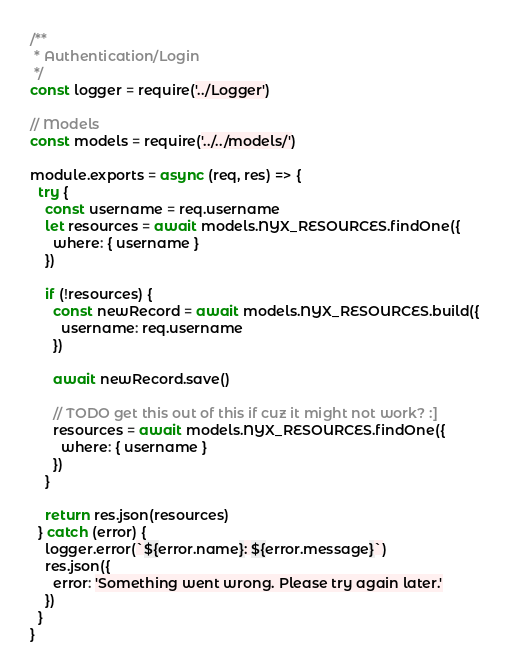<code> <loc_0><loc_0><loc_500><loc_500><_JavaScript_>/**
 * Authentication/Login
 */
const logger = require('../Logger')

// Models
const models = require('../../models/')

module.exports = async (req, res) => {
  try {
    const username = req.username
    let resources = await models.NYX_RESOURCES.findOne({
      where: { username }
    })

    if (!resources) {
      const newRecord = await models.NYX_RESOURCES.build({
        username: req.username
      })

      await newRecord.save()

      // TODO get this out of this if cuz it might not work? :]
      resources = await models.NYX_RESOURCES.findOne({
        where: { username }
      })
    }

    return res.json(resources)
  } catch (error) {
    logger.error(`${error.name}: ${error.message}`)
    res.json({
      error: 'Something went wrong. Please try again later.'
    })
  }
}
</code> 